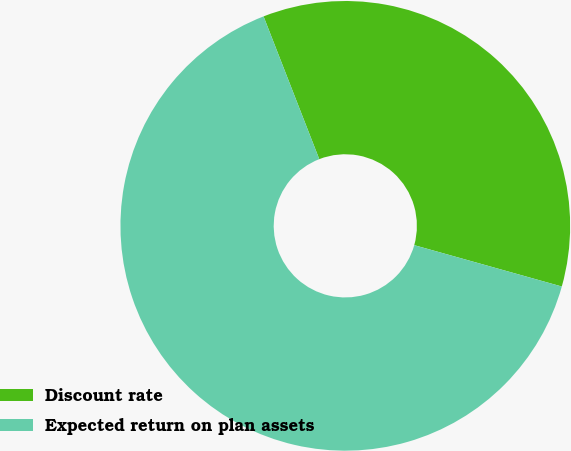Convert chart to OTSL. <chart><loc_0><loc_0><loc_500><loc_500><pie_chart><fcel>Discount rate<fcel>Expected return on plan assets<nl><fcel>35.27%<fcel>64.73%<nl></chart> 